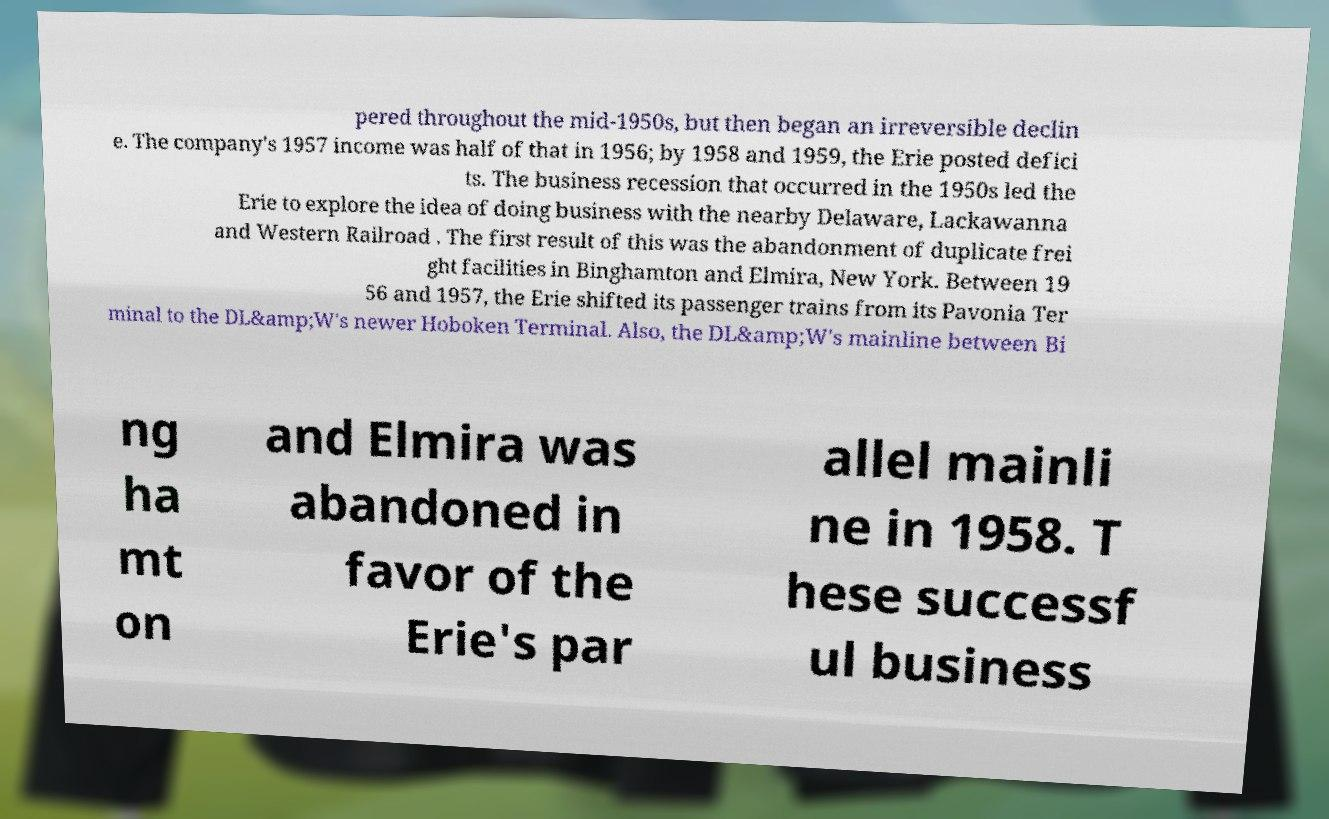Could you assist in decoding the text presented in this image and type it out clearly? pered throughout the mid-1950s, but then began an irreversible declin e. The company's 1957 income was half of that in 1956; by 1958 and 1959, the Erie posted defici ts. The business recession that occurred in the 1950s led the Erie to explore the idea of doing business with the nearby Delaware, Lackawanna and Western Railroad . The first result of this was the abandonment of duplicate frei ght facilities in Binghamton and Elmira, New York. Between 19 56 and 1957, the Erie shifted its passenger trains from its Pavonia Ter minal to the DL&amp;W's newer Hoboken Terminal. Also, the DL&amp;W's mainline between Bi ng ha mt on and Elmira was abandoned in favor of the Erie's par allel mainli ne in 1958. T hese successf ul business 